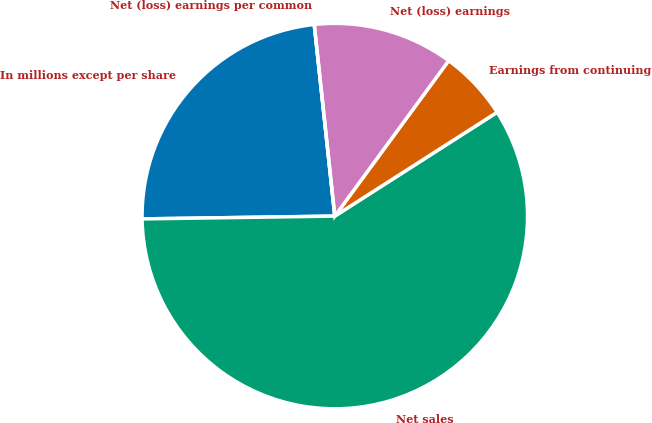Convert chart. <chart><loc_0><loc_0><loc_500><loc_500><pie_chart><fcel>In millions except per share<fcel>Net sales<fcel>Earnings from continuing<fcel>Net (loss) earnings<fcel>Net (loss) earnings per common<nl><fcel>23.53%<fcel>58.82%<fcel>5.88%<fcel>11.76%<fcel>0.0%<nl></chart> 